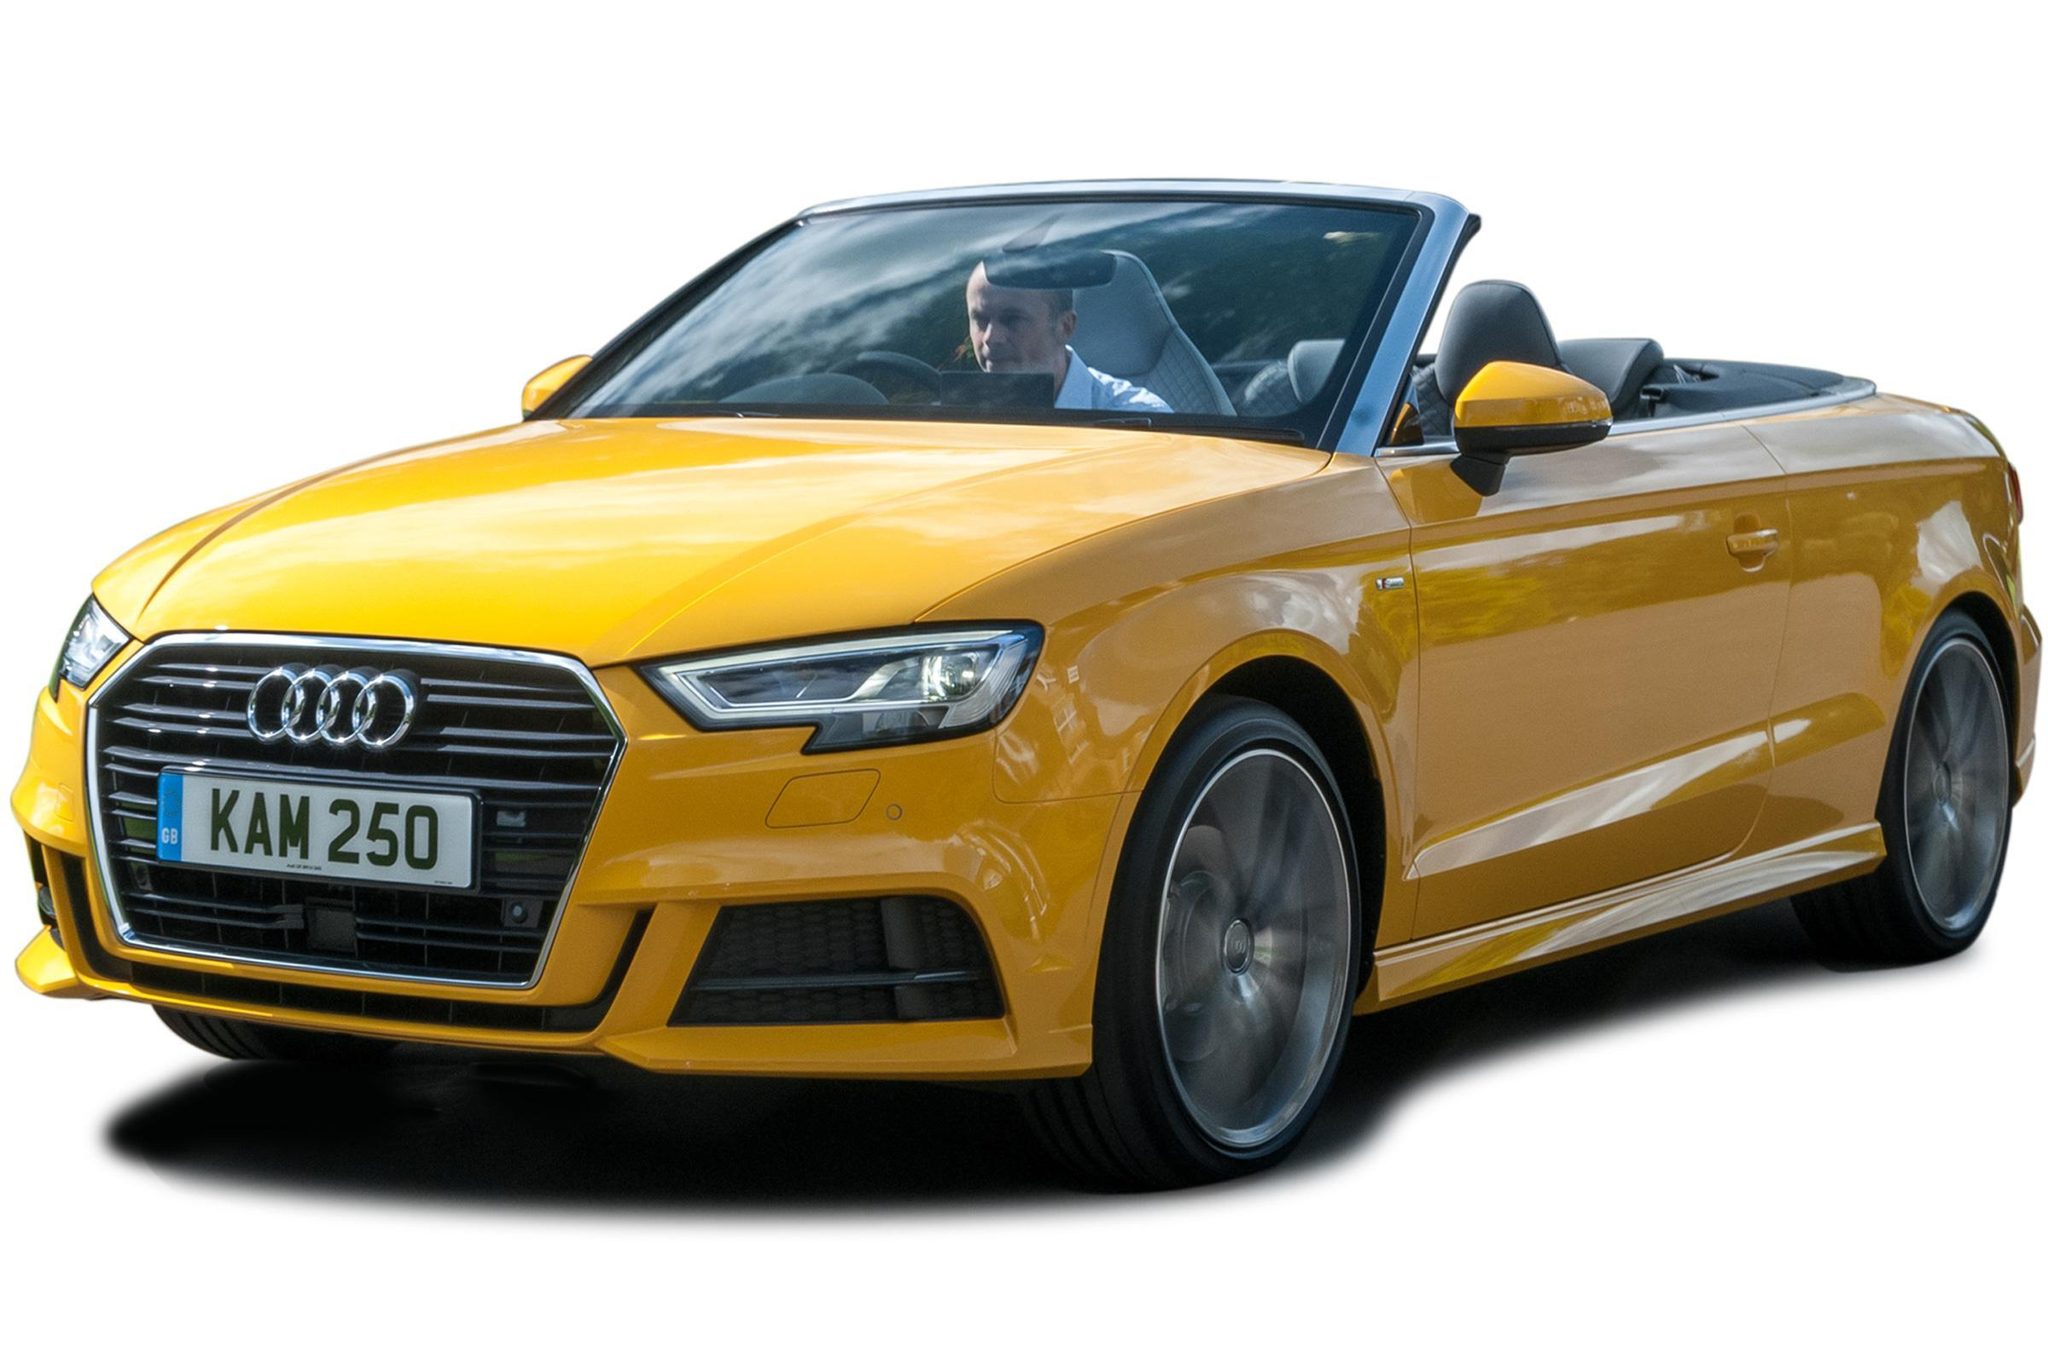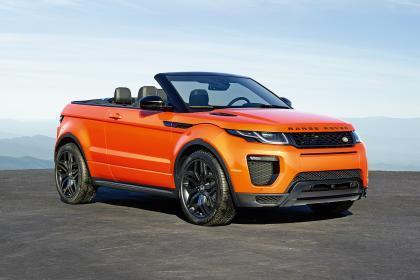The first image is the image on the left, the second image is the image on the right. Considering the images on both sides, is "The left image contains a red convertible vehicle." valid? Answer yes or no. No. The first image is the image on the left, the second image is the image on the right. Given the left and right images, does the statement "The left image features a red convertible car with its top down" hold true? Answer yes or no. No. 